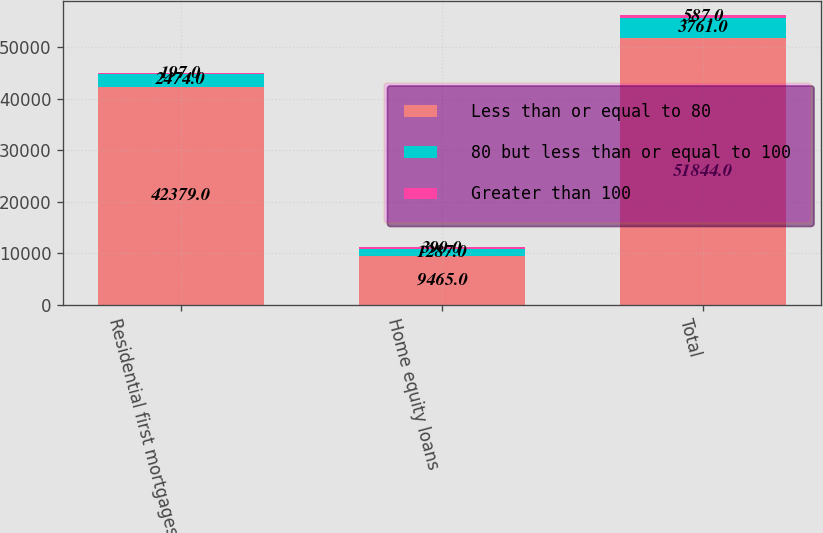<chart> <loc_0><loc_0><loc_500><loc_500><stacked_bar_chart><ecel><fcel>Residential first mortgages<fcel>Home equity loans<fcel>Total<nl><fcel>Less than or equal to 80<fcel>42379<fcel>9465<fcel>51844<nl><fcel>80 but less than or equal to 100<fcel>2474<fcel>1287<fcel>3761<nl><fcel>Greater than 100<fcel>197<fcel>390<fcel>587<nl></chart> 